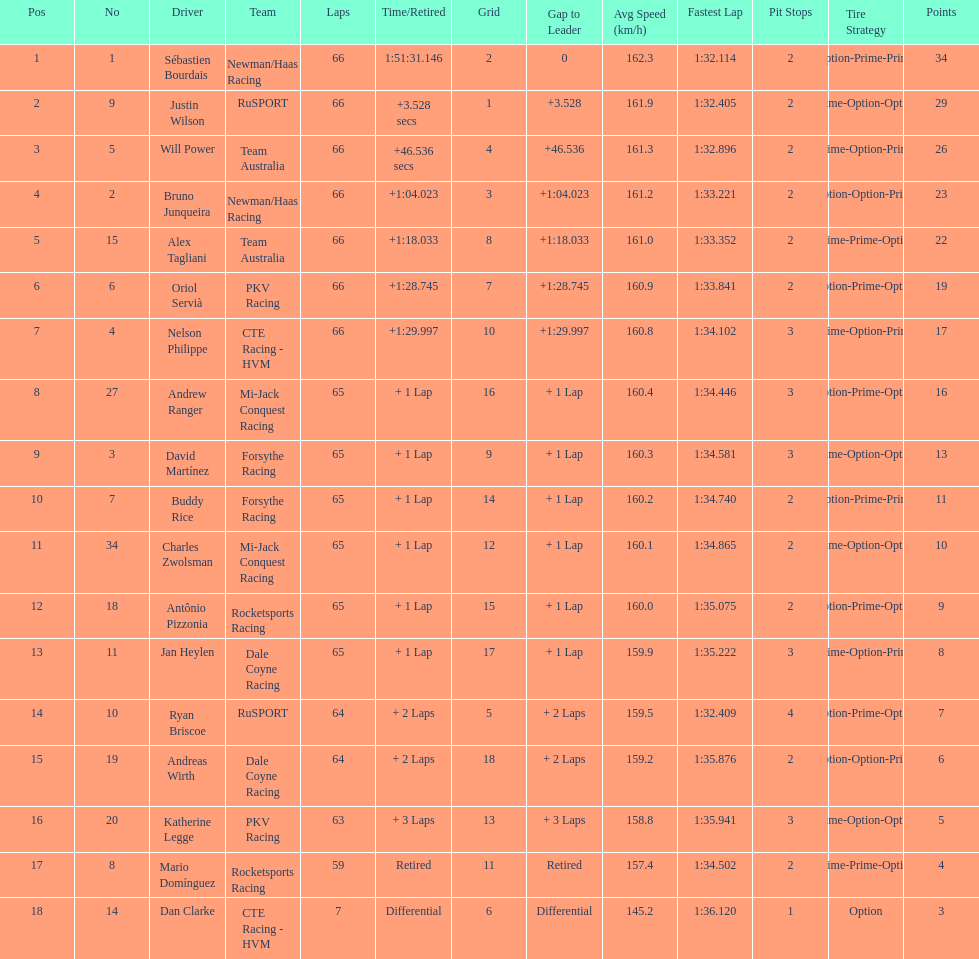What are the names of the drivers who were in position 14 through position 18? Ryan Briscoe, Andreas Wirth, Katherine Legge, Mario Domínguez, Dan Clarke. Of these , which ones didn't finish due to retired or differential? Mario Domínguez, Dan Clarke. Which one of the previous drivers retired? Mario Domínguez. Which of the drivers in question 2 had a differential? Dan Clarke. 